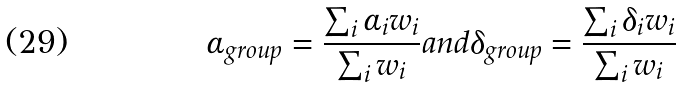Convert formula to latex. <formula><loc_0><loc_0><loc_500><loc_500>\alpha _ { g r o u p } = \frac { \sum _ { i } \alpha _ { i } w _ { i } } { \sum _ { i } w _ { i } } a n d \delta _ { g r o u p } = \frac { \sum _ { i } \delta _ { i } w _ { i } } { \sum _ { i } w _ { i } }</formula> 